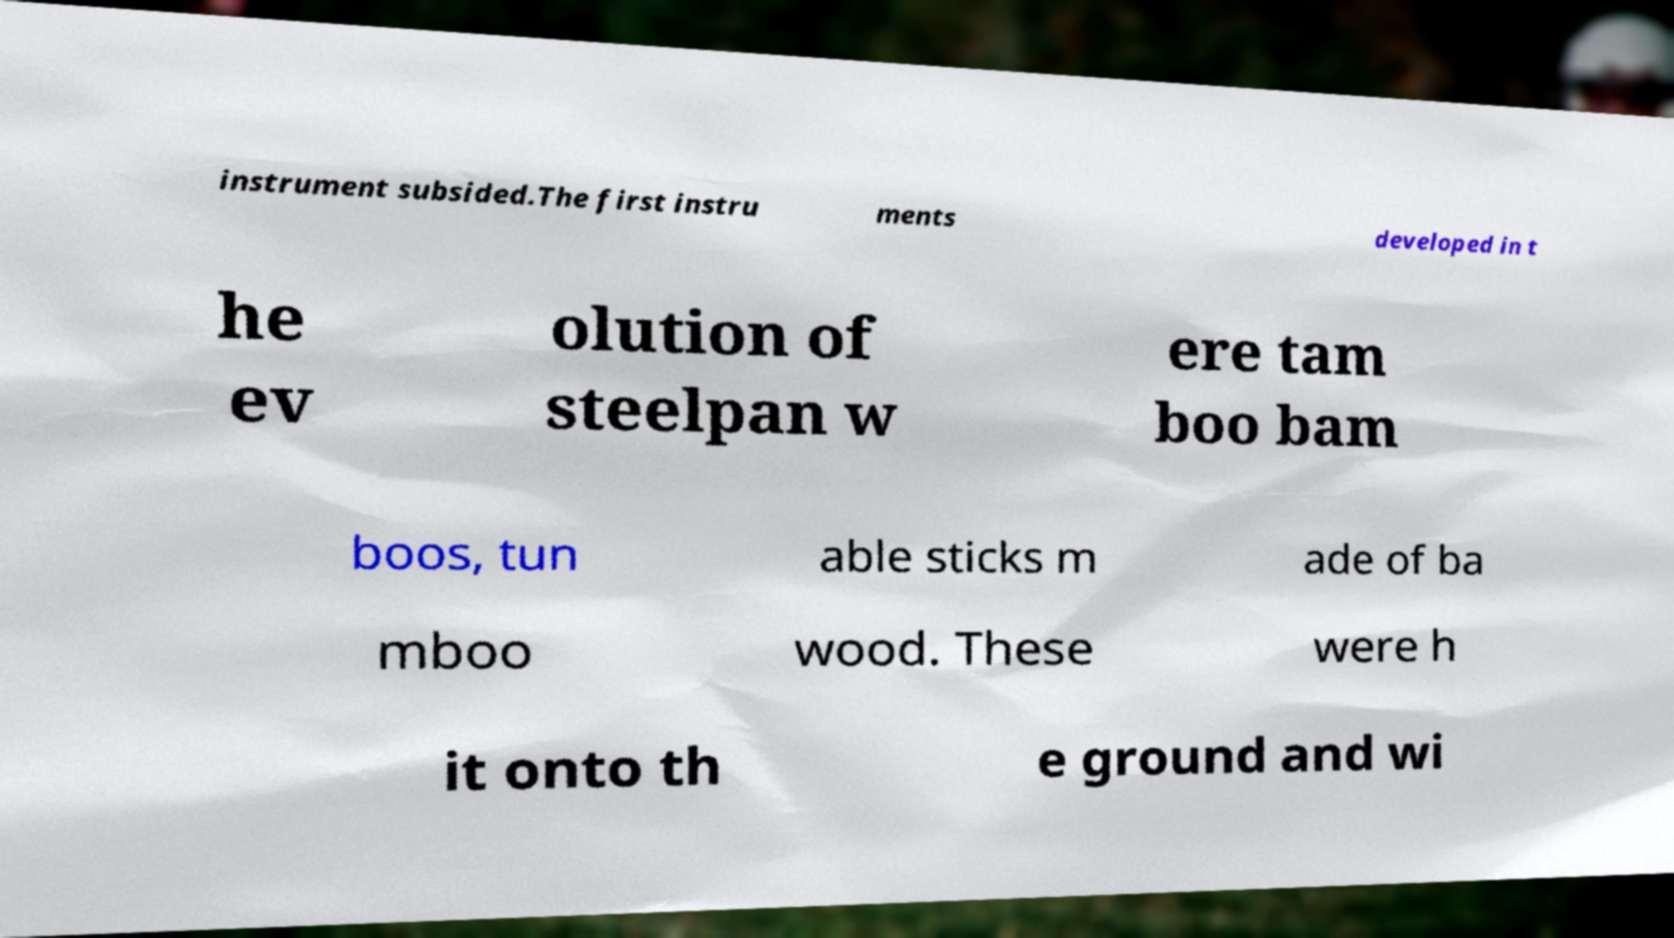Could you extract and type out the text from this image? instrument subsided.The first instru ments developed in t he ev olution of steelpan w ere tam boo bam boos, tun able sticks m ade of ba mboo wood. These were h it onto th e ground and wi 